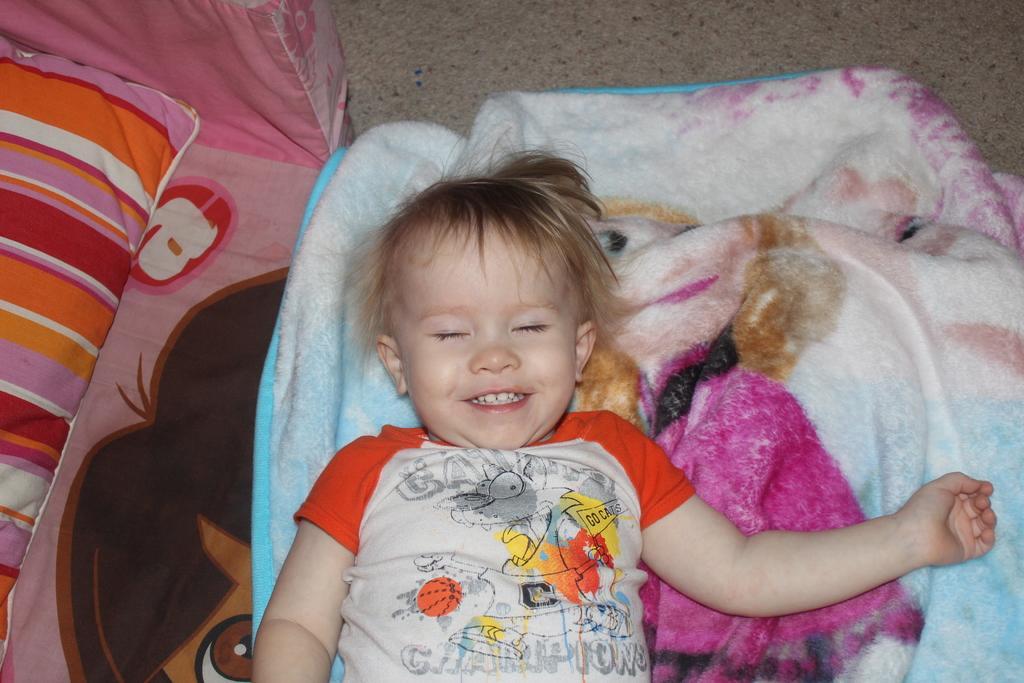Can you describe this image briefly? In this picture we can see a kid is lying and smiling, at the bottom there is a cloth, we can see a pillow on the left side, at the bottom we can also see bed sheet. 